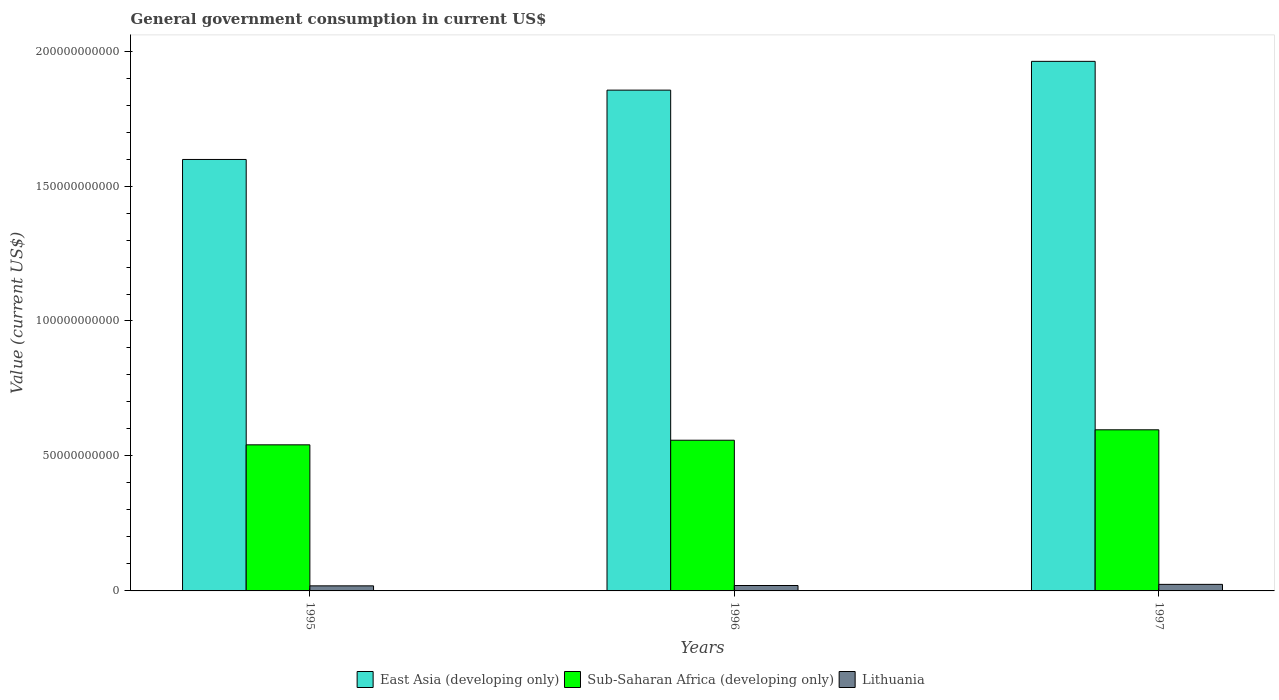How many different coloured bars are there?
Offer a very short reply. 3. How many groups of bars are there?
Provide a succinct answer. 3. Are the number of bars per tick equal to the number of legend labels?
Your answer should be very brief. Yes. Are the number of bars on each tick of the X-axis equal?
Make the answer very short. Yes. How many bars are there on the 2nd tick from the right?
Give a very brief answer. 3. What is the label of the 2nd group of bars from the left?
Make the answer very short. 1996. What is the government conusmption in Lithuania in 1996?
Give a very brief answer. 2.00e+09. Across all years, what is the maximum government conusmption in Lithuania?
Ensure brevity in your answer.  2.43e+09. Across all years, what is the minimum government conusmption in Sub-Saharan Africa (developing only)?
Make the answer very short. 5.41e+1. What is the total government conusmption in East Asia (developing only) in the graph?
Your response must be concise. 5.42e+11. What is the difference between the government conusmption in East Asia (developing only) in 1996 and that in 1997?
Keep it short and to the point. -1.07e+1. What is the difference between the government conusmption in Lithuania in 1997 and the government conusmption in East Asia (developing only) in 1995?
Provide a succinct answer. -1.57e+11. What is the average government conusmption in East Asia (developing only) per year?
Your answer should be very brief. 1.81e+11. In the year 1995, what is the difference between the government conusmption in East Asia (developing only) and government conusmption in Lithuania?
Your answer should be very brief. 1.58e+11. What is the ratio of the government conusmption in Sub-Saharan Africa (developing only) in 1995 to that in 1996?
Make the answer very short. 0.97. What is the difference between the highest and the second highest government conusmption in East Asia (developing only)?
Your answer should be compact. 1.07e+1. What is the difference between the highest and the lowest government conusmption in Lithuania?
Make the answer very short. 5.50e+08. In how many years, is the government conusmption in Lithuania greater than the average government conusmption in Lithuania taken over all years?
Give a very brief answer. 1. What does the 1st bar from the left in 1997 represents?
Give a very brief answer. East Asia (developing only). What does the 1st bar from the right in 1995 represents?
Your answer should be compact. Lithuania. Are all the bars in the graph horizontal?
Your response must be concise. No. How many years are there in the graph?
Provide a short and direct response. 3. What is the difference between two consecutive major ticks on the Y-axis?
Make the answer very short. 5.00e+1. Are the values on the major ticks of Y-axis written in scientific E-notation?
Ensure brevity in your answer.  No. Does the graph contain grids?
Offer a very short reply. No. How are the legend labels stacked?
Give a very brief answer. Horizontal. What is the title of the graph?
Offer a very short reply. General government consumption in current US$. What is the label or title of the Y-axis?
Keep it short and to the point. Value (current US$). What is the Value (current US$) of East Asia (developing only) in 1995?
Give a very brief answer. 1.60e+11. What is the Value (current US$) of Sub-Saharan Africa (developing only) in 1995?
Offer a terse response. 5.41e+1. What is the Value (current US$) in Lithuania in 1995?
Offer a terse response. 1.88e+09. What is the Value (current US$) in East Asia (developing only) in 1996?
Make the answer very short. 1.86e+11. What is the Value (current US$) in Sub-Saharan Africa (developing only) in 1996?
Offer a terse response. 5.58e+1. What is the Value (current US$) of Lithuania in 1996?
Provide a succinct answer. 2.00e+09. What is the Value (current US$) in East Asia (developing only) in 1997?
Make the answer very short. 1.96e+11. What is the Value (current US$) of Sub-Saharan Africa (developing only) in 1997?
Offer a terse response. 5.97e+1. What is the Value (current US$) of Lithuania in 1997?
Provide a short and direct response. 2.43e+09. Across all years, what is the maximum Value (current US$) of East Asia (developing only)?
Ensure brevity in your answer.  1.96e+11. Across all years, what is the maximum Value (current US$) in Sub-Saharan Africa (developing only)?
Offer a very short reply. 5.97e+1. Across all years, what is the maximum Value (current US$) in Lithuania?
Make the answer very short. 2.43e+09. Across all years, what is the minimum Value (current US$) in East Asia (developing only)?
Ensure brevity in your answer.  1.60e+11. Across all years, what is the minimum Value (current US$) in Sub-Saharan Africa (developing only)?
Your answer should be compact. 5.41e+1. Across all years, what is the minimum Value (current US$) in Lithuania?
Provide a succinct answer. 1.88e+09. What is the total Value (current US$) in East Asia (developing only) in the graph?
Your response must be concise. 5.42e+11. What is the total Value (current US$) of Sub-Saharan Africa (developing only) in the graph?
Give a very brief answer. 1.70e+11. What is the total Value (current US$) of Lithuania in the graph?
Your response must be concise. 6.31e+09. What is the difference between the Value (current US$) in East Asia (developing only) in 1995 and that in 1996?
Ensure brevity in your answer.  -2.57e+1. What is the difference between the Value (current US$) of Sub-Saharan Africa (developing only) in 1995 and that in 1996?
Provide a short and direct response. -1.71e+09. What is the difference between the Value (current US$) in Lithuania in 1995 and that in 1996?
Your answer should be very brief. -1.28e+08. What is the difference between the Value (current US$) in East Asia (developing only) in 1995 and that in 1997?
Your response must be concise. -3.63e+1. What is the difference between the Value (current US$) of Sub-Saharan Africa (developing only) in 1995 and that in 1997?
Your answer should be compact. -5.56e+09. What is the difference between the Value (current US$) in Lithuania in 1995 and that in 1997?
Keep it short and to the point. -5.50e+08. What is the difference between the Value (current US$) of East Asia (developing only) in 1996 and that in 1997?
Ensure brevity in your answer.  -1.07e+1. What is the difference between the Value (current US$) in Sub-Saharan Africa (developing only) in 1996 and that in 1997?
Offer a terse response. -3.86e+09. What is the difference between the Value (current US$) of Lithuania in 1996 and that in 1997?
Provide a short and direct response. -4.23e+08. What is the difference between the Value (current US$) in East Asia (developing only) in 1995 and the Value (current US$) in Sub-Saharan Africa (developing only) in 1996?
Your answer should be very brief. 1.04e+11. What is the difference between the Value (current US$) in East Asia (developing only) in 1995 and the Value (current US$) in Lithuania in 1996?
Keep it short and to the point. 1.58e+11. What is the difference between the Value (current US$) in Sub-Saharan Africa (developing only) in 1995 and the Value (current US$) in Lithuania in 1996?
Offer a very short reply. 5.21e+1. What is the difference between the Value (current US$) in East Asia (developing only) in 1995 and the Value (current US$) in Sub-Saharan Africa (developing only) in 1997?
Provide a short and direct response. 1.00e+11. What is the difference between the Value (current US$) in East Asia (developing only) in 1995 and the Value (current US$) in Lithuania in 1997?
Offer a very short reply. 1.57e+11. What is the difference between the Value (current US$) in Sub-Saharan Africa (developing only) in 1995 and the Value (current US$) in Lithuania in 1997?
Make the answer very short. 5.17e+1. What is the difference between the Value (current US$) of East Asia (developing only) in 1996 and the Value (current US$) of Sub-Saharan Africa (developing only) in 1997?
Give a very brief answer. 1.26e+11. What is the difference between the Value (current US$) in East Asia (developing only) in 1996 and the Value (current US$) in Lithuania in 1997?
Your answer should be very brief. 1.83e+11. What is the difference between the Value (current US$) of Sub-Saharan Africa (developing only) in 1996 and the Value (current US$) of Lithuania in 1997?
Your answer should be compact. 5.34e+1. What is the average Value (current US$) of East Asia (developing only) per year?
Make the answer very short. 1.81e+11. What is the average Value (current US$) in Sub-Saharan Africa (developing only) per year?
Provide a succinct answer. 5.65e+1. What is the average Value (current US$) of Lithuania per year?
Offer a terse response. 2.10e+09. In the year 1995, what is the difference between the Value (current US$) of East Asia (developing only) and Value (current US$) of Sub-Saharan Africa (developing only)?
Provide a succinct answer. 1.06e+11. In the year 1995, what is the difference between the Value (current US$) of East Asia (developing only) and Value (current US$) of Lithuania?
Provide a short and direct response. 1.58e+11. In the year 1995, what is the difference between the Value (current US$) of Sub-Saharan Africa (developing only) and Value (current US$) of Lithuania?
Your answer should be compact. 5.22e+1. In the year 1996, what is the difference between the Value (current US$) of East Asia (developing only) and Value (current US$) of Sub-Saharan Africa (developing only)?
Provide a succinct answer. 1.30e+11. In the year 1996, what is the difference between the Value (current US$) of East Asia (developing only) and Value (current US$) of Lithuania?
Your response must be concise. 1.84e+11. In the year 1996, what is the difference between the Value (current US$) of Sub-Saharan Africa (developing only) and Value (current US$) of Lithuania?
Make the answer very short. 5.38e+1. In the year 1997, what is the difference between the Value (current US$) of East Asia (developing only) and Value (current US$) of Sub-Saharan Africa (developing only)?
Your answer should be compact. 1.37e+11. In the year 1997, what is the difference between the Value (current US$) in East Asia (developing only) and Value (current US$) in Lithuania?
Provide a succinct answer. 1.94e+11. In the year 1997, what is the difference between the Value (current US$) in Sub-Saharan Africa (developing only) and Value (current US$) in Lithuania?
Provide a succinct answer. 5.73e+1. What is the ratio of the Value (current US$) in East Asia (developing only) in 1995 to that in 1996?
Offer a terse response. 0.86. What is the ratio of the Value (current US$) of Sub-Saharan Africa (developing only) in 1995 to that in 1996?
Offer a terse response. 0.97. What is the ratio of the Value (current US$) in Lithuania in 1995 to that in 1996?
Give a very brief answer. 0.94. What is the ratio of the Value (current US$) of East Asia (developing only) in 1995 to that in 1997?
Provide a succinct answer. 0.81. What is the ratio of the Value (current US$) of Sub-Saharan Africa (developing only) in 1995 to that in 1997?
Your answer should be compact. 0.91. What is the ratio of the Value (current US$) of Lithuania in 1995 to that in 1997?
Your answer should be compact. 0.77. What is the ratio of the Value (current US$) of East Asia (developing only) in 1996 to that in 1997?
Your answer should be very brief. 0.95. What is the ratio of the Value (current US$) in Sub-Saharan Africa (developing only) in 1996 to that in 1997?
Keep it short and to the point. 0.94. What is the ratio of the Value (current US$) of Lithuania in 1996 to that in 1997?
Provide a short and direct response. 0.83. What is the difference between the highest and the second highest Value (current US$) in East Asia (developing only)?
Give a very brief answer. 1.07e+1. What is the difference between the highest and the second highest Value (current US$) of Sub-Saharan Africa (developing only)?
Offer a terse response. 3.86e+09. What is the difference between the highest and the second highest Value (current US$) in Lithuania?
Your answer should be compact. 4.23e+08. What is the difference between the highest and the lowest Value (current US$) of East Asia (developing only)?
Your answer should be very brief. 3.63e+1. What is the difference between the highest and the lowest Value (current US$) of Sub-Saharan Africa (developing only)?
Give a very brief answer. 5.56e+09. What is the difference between the highest and the lowest Value (current US$) in Lithuania?
Provide a succinct answer. 5.50e+08. 